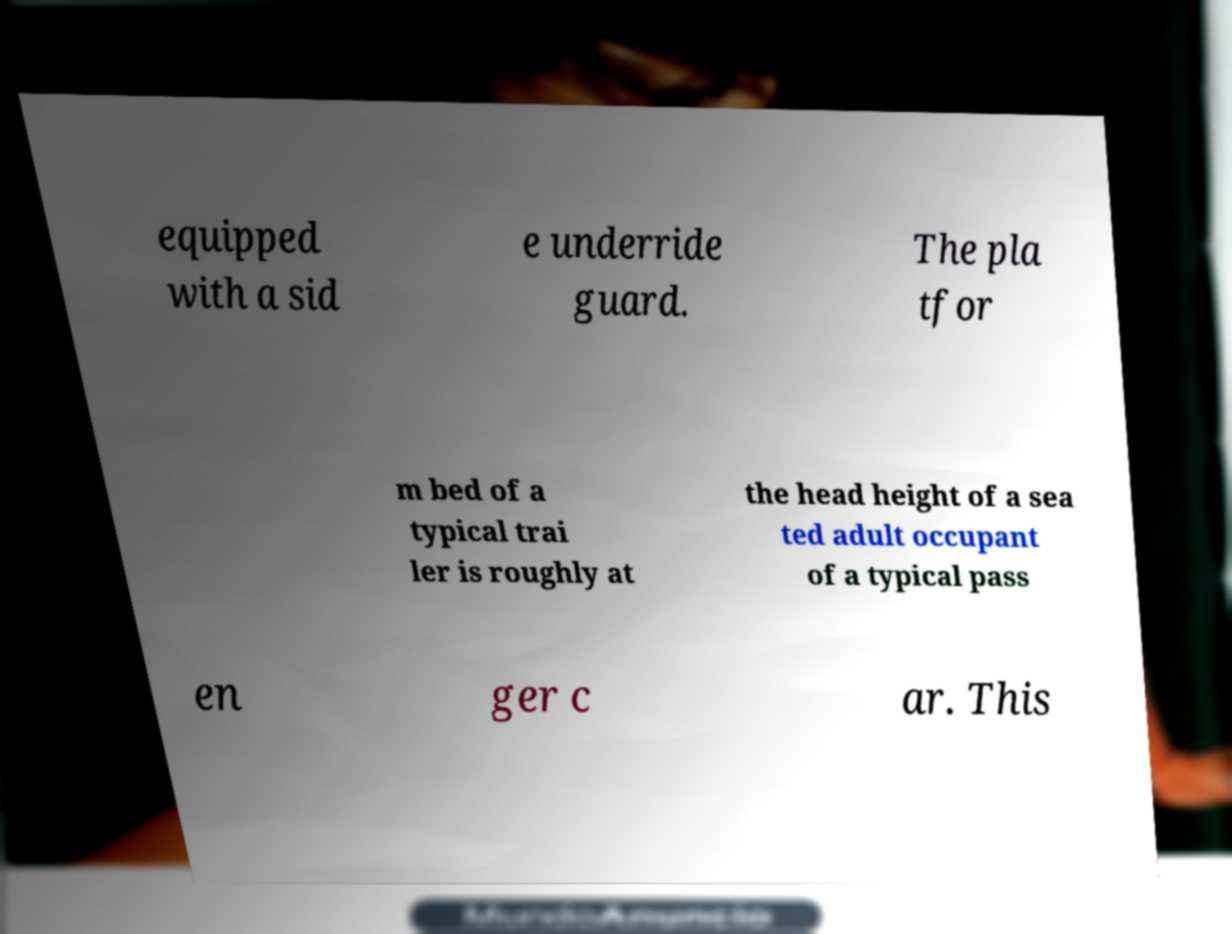What messages or text are displayed in this image? I need them in a readable, typed format. equipped with a sid e underride guard. The pla tfor m bed of a typical trai ler is roughly at the head height of a sea ted adult occupant of a typical pass en ger c ar. This 